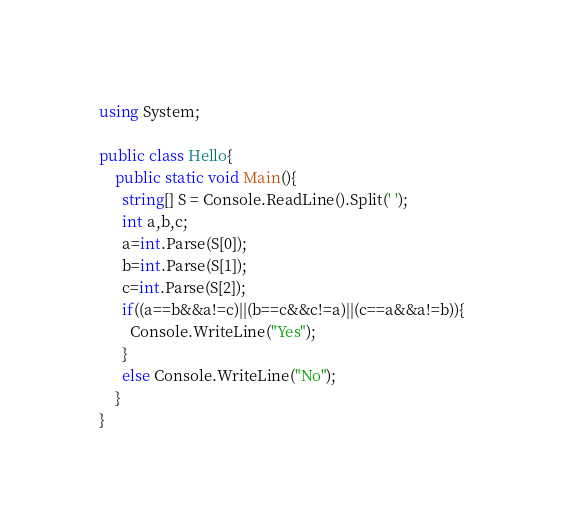Convert code to text. <code><loc_0><loc_0><loc_500><loc_500><_C#_>using System;

public class Hello{
	public static void Main(){
	  string[] S = Console.ReadLine().Split(' ');
      int a,b,c;
      a=int.Parse(S[0]);
      b=int.Parse(S[1]);
      c=int.Parse(S[2]);
      if((a==b&&a!=c)||(b==c&&c!=a)||(c==a&&a!=b)){
        Console.WriteLine("Yes");
      }
      else Console.WriteLine("No");
	}
} 
</code> 